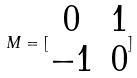<formula> <loc_0><loc_0><loc_500><loc_500>M = [ \begin{matrix} 0 & 1 \\ - 1 & 0 \end{matrix} ]</formula> 